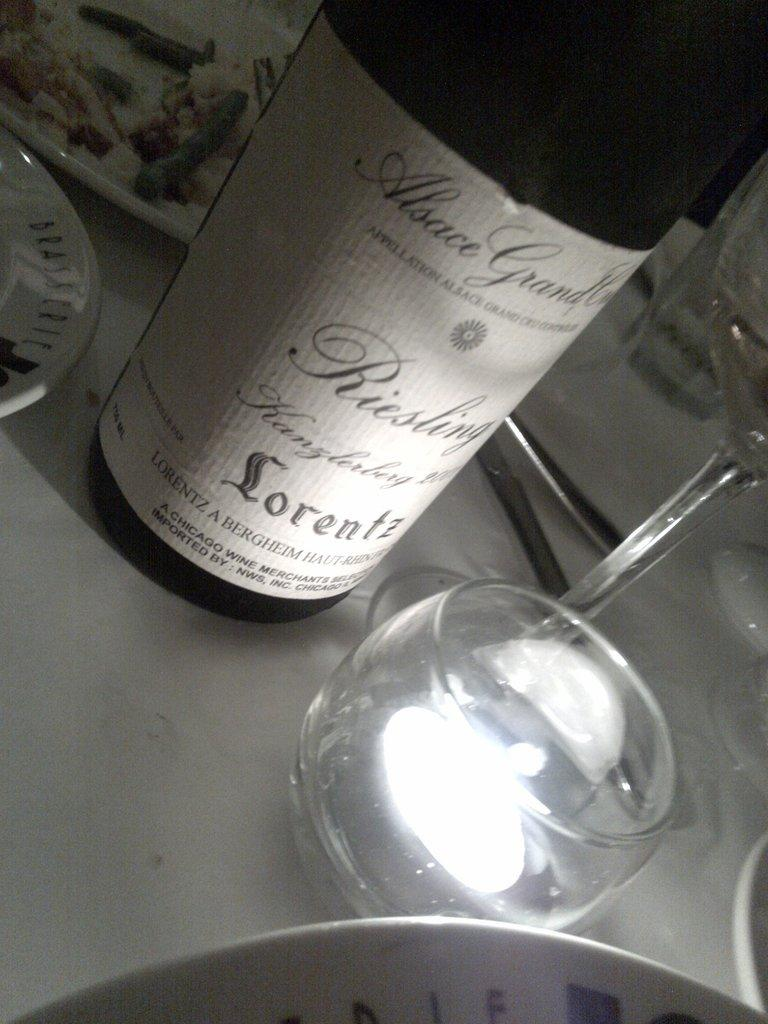<image>
Write a terse but informative summary of the picture. the word lorentz that is on a bottle 